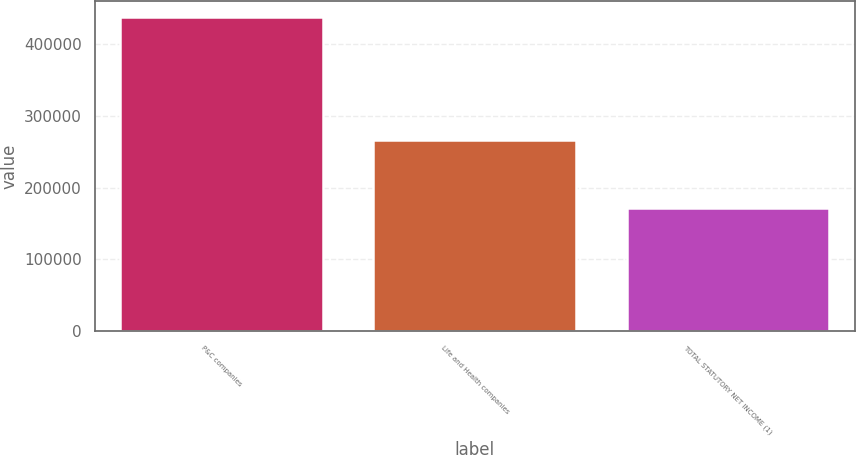Convert chart. <chart><loc_0><loc_0><loc_500><loc_500><bar_chart><fcel>P&C companies<fcel>Life and Health companies<fcel>TOTAL STATUTORY NET INCOME (1)<nl><fcel>437422<fcel>266559<fcel>170863<nl></chart> 